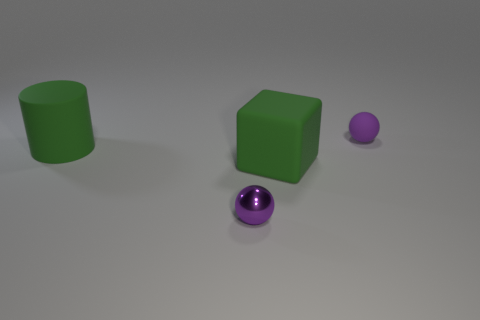What number of cubes are either green things or small objects?
Your answer should be compact. 1. How big is the object that is behind the green matte thing on the left side of the large green matte object in front of the rubber cylinder?
Offer a terse response. Small. There is a small purple metallic object; are there any rubber blocks to the left of it?
Your answer should be very brief. No. The thing that is the same color as the rubber cube is what shape?
Your answer should be very brief. Cylinder. How many things are either balls that are on the left side of the tiny matte thing or small matte balls?
Ensure brevity in your answer.  2. The purple ball that is the same material as the block is what size?
Ensure brevity in your answer.  Small. Do the purple metallic thing and the green matte cylinder to the left of the big green rubber block have the same size?
Your response must be concise. No. What color is the object that is both behind the tiny purple shiny sphere and to the left of the large green block?
Ensure brevity in your answer.  Green. How many objects are either matte things that are left of the tiny purple matte object or small spheres that are to the right of the cube?
Keep it short and to the point. 3. The ball in front of the green object on the left side of the metallic thing that is in front of the tiny purple rubber ball is what color?
Your answer should be very brief. Purple. 